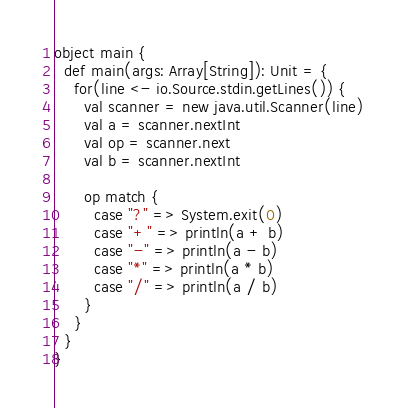<code> <loc_0><loc_0><loc_500><loc_500><_Scala_>object main {
  def main(args: Array[String]): Unit = {
    for(line <- io.Source.stdin.getLines()) {
      val scanner = new java.util.Scanner(line)
      val a = scanner.nextInt
      val op = scanner.next
      val b = scanner.nextInt

      op match {
        case "?" => System.exit(0)
        case "+" => println(a + b)
        case "-" => println(a - b)
        case "*" => println(a * b)
        case "/" => println(a / b)
      }
    }
  }
}
</code> 